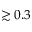<formula> <loc_0><loc_0><loc_500><loc_500>\gtrsim 0 . 3</formula> 